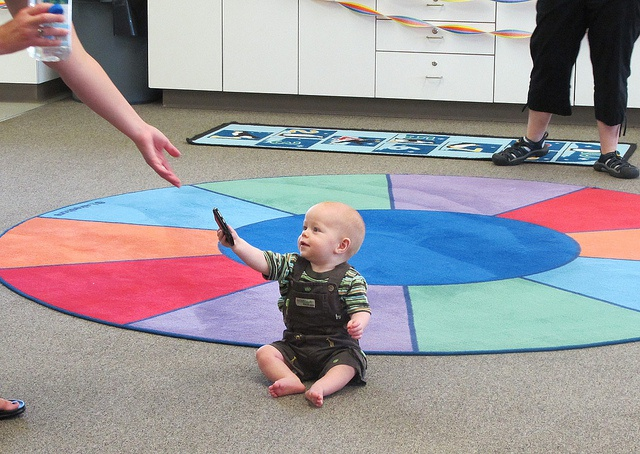Describe the objects in this image and their specific colors. I can see people in lightgray, black, lightpink, gray, and brown tones, people in lightgray, black, gray, and darkgray tones, people in lightgray, brown, lightpink, and darkgray tones, bottle in lightgray, darkgray, lavender, lightpink, and lightblue tones, and cell phone in lightgray, black, gray, maroon, and purple tones in this image. 